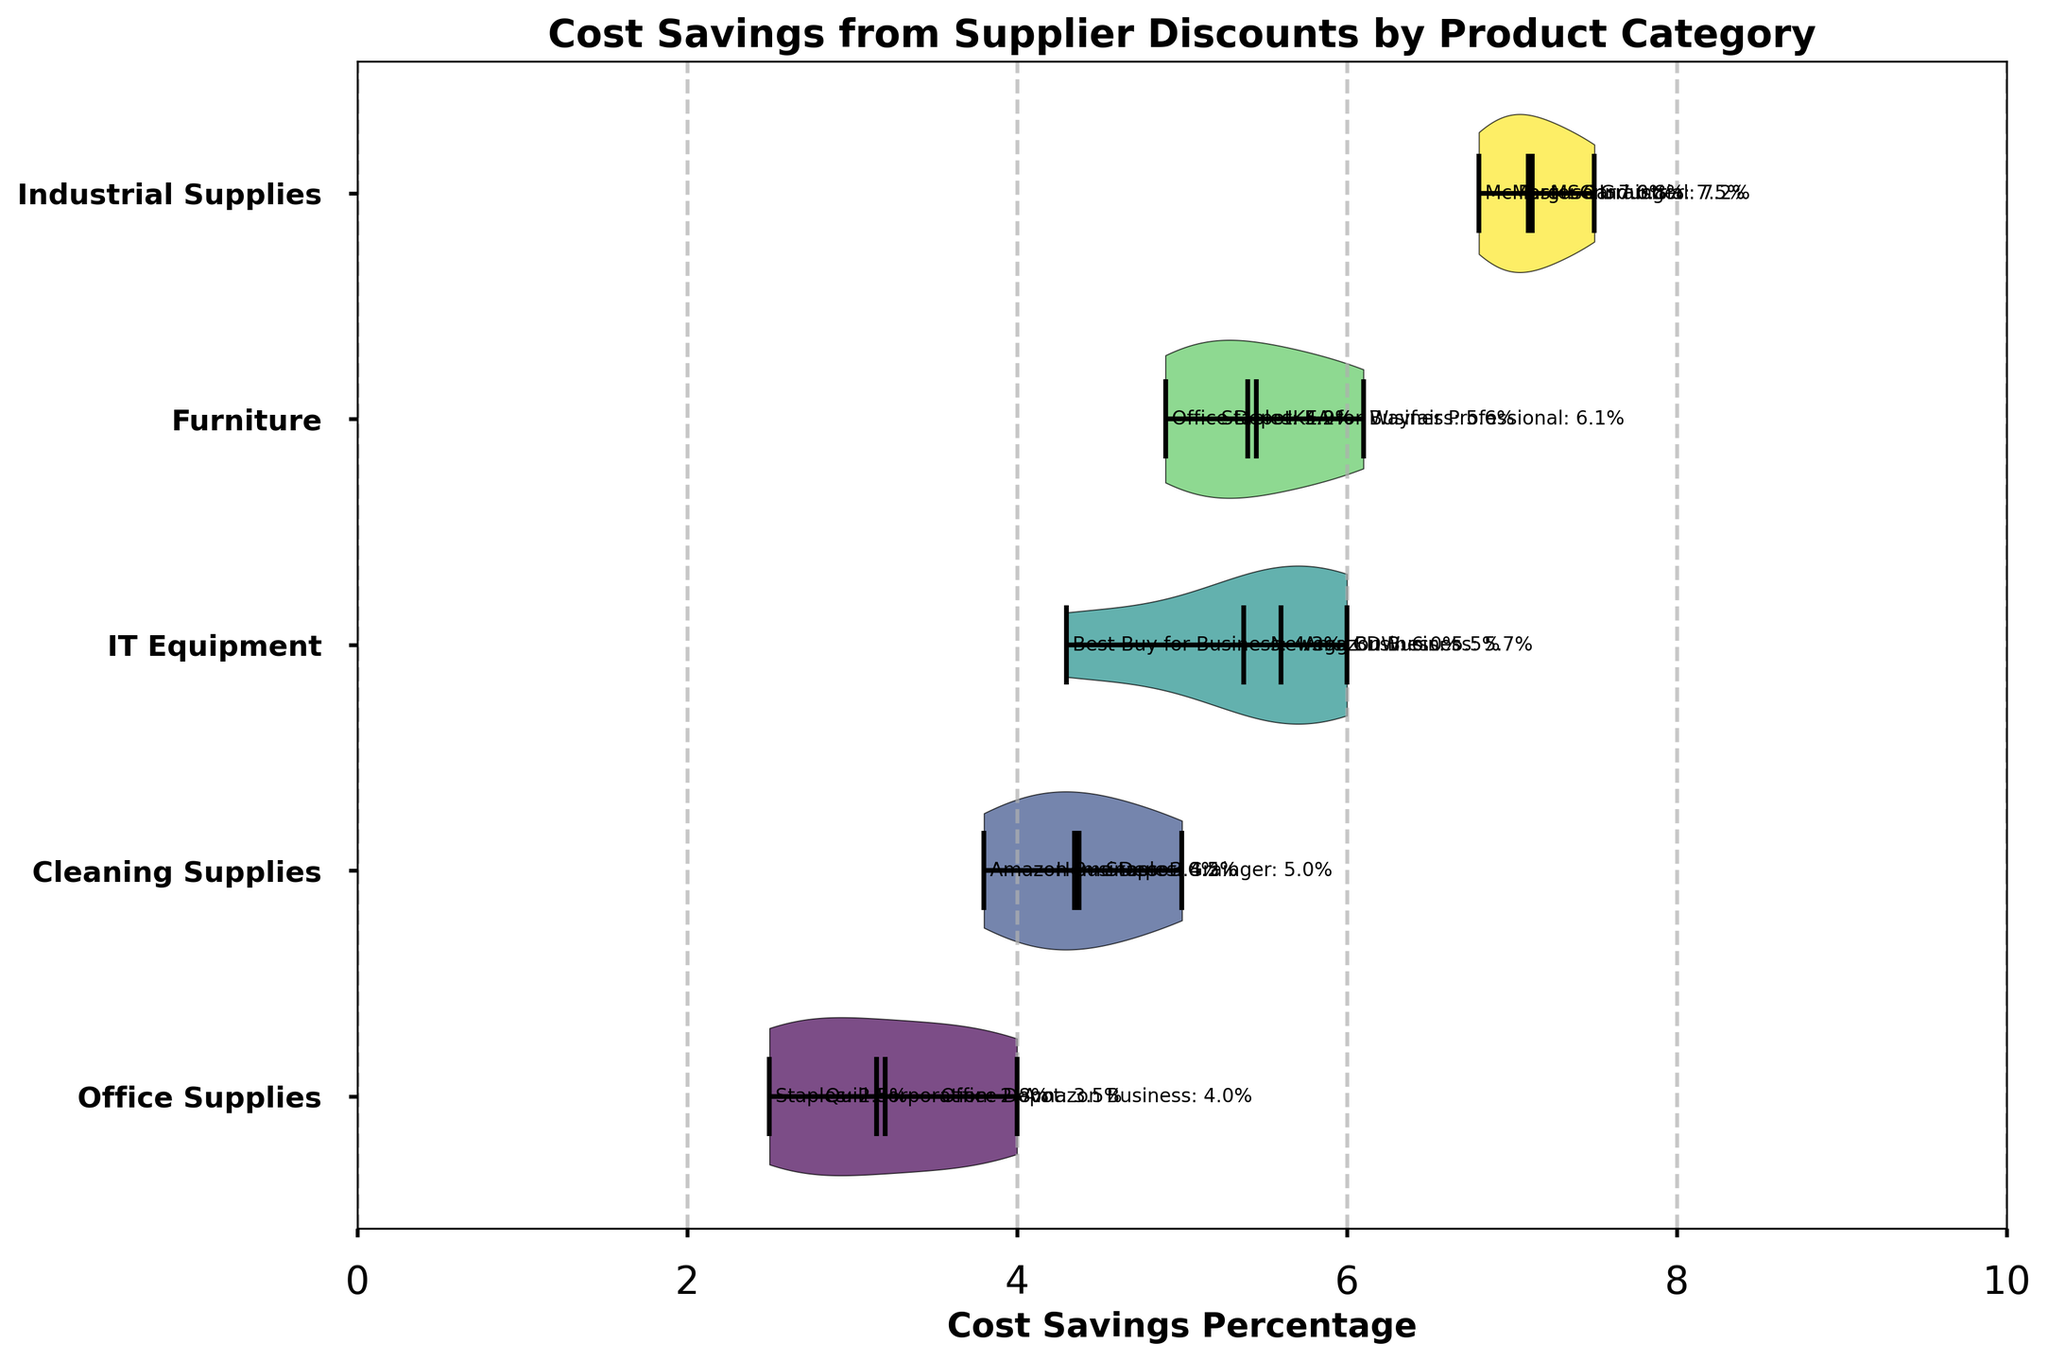What is the title of the chart? The title of the chart is written at the top of the figure. It indicates the purpose of the chart and what data it represents.
Answer: Cost Savings from Supplier Discounts by Product Category Which product category has the highest median cost savings percentage? To determine the highest median cost savings percentage, look at the thick horizontal line in the center of each violin plot. Find the one that is positioned highest on the x-axis.
Answer: Industrial Supplies What color represents the Cleaning Supplies category? The color representing each category can be determined by looking at the shades used in the violin plots. Each product category has a different color.
Answer: Light Green How many suppliers have data points for IT Equipment? Count the number of data points (or labels) aligned horizontally for the IT Equipment category in the plot.
Answer: 4 Which supplier offers the highest cost savings percentage in the Furniture category? Look at the individual data points in the Furniture violin plot and identify the highest value. Then, refer to the labels next to the value to find the supplier's name.
Answer: Wayfair Professional What is the mean cost savings percentage for Office Supplies? Identify the mean marking (typically shown with a different symbol or line) in the Office Supplies violin plot and read its value on the x-axis.
Answer: Around 3.2 Which product category has the widest distribution of cost savings percentages? Assess the width of each violin plot. The wider the plot, the more varied the data points are.
Answer: IT Equipment What's the difference between the highest and lowest cost savings percentage for Cleaning Supplies? Locate the highest and lowest points on the Cleaning Supplies violin plot and subtract the lowest from the highest to get the range.
Answer: 1.2 (5.0 - 3.8 = 1.2) How do the distributions of cost savings percentages compare between Office Supplies and IT Equipment? Compare the shapes and widths of the Office Supplies and IT Equipment violin plots. Look at the range, median, and overall spread of data points for each category.
Answer: IT Equipment has a wider range and higher savings percentages Which product category has the smallest range in cost savings percentages? Determine the range in each category by finding the distance between the maximum and minimum points in their respective violin plots. The category with the shortest distance has the smallest range.
Answer: Office Supplies 